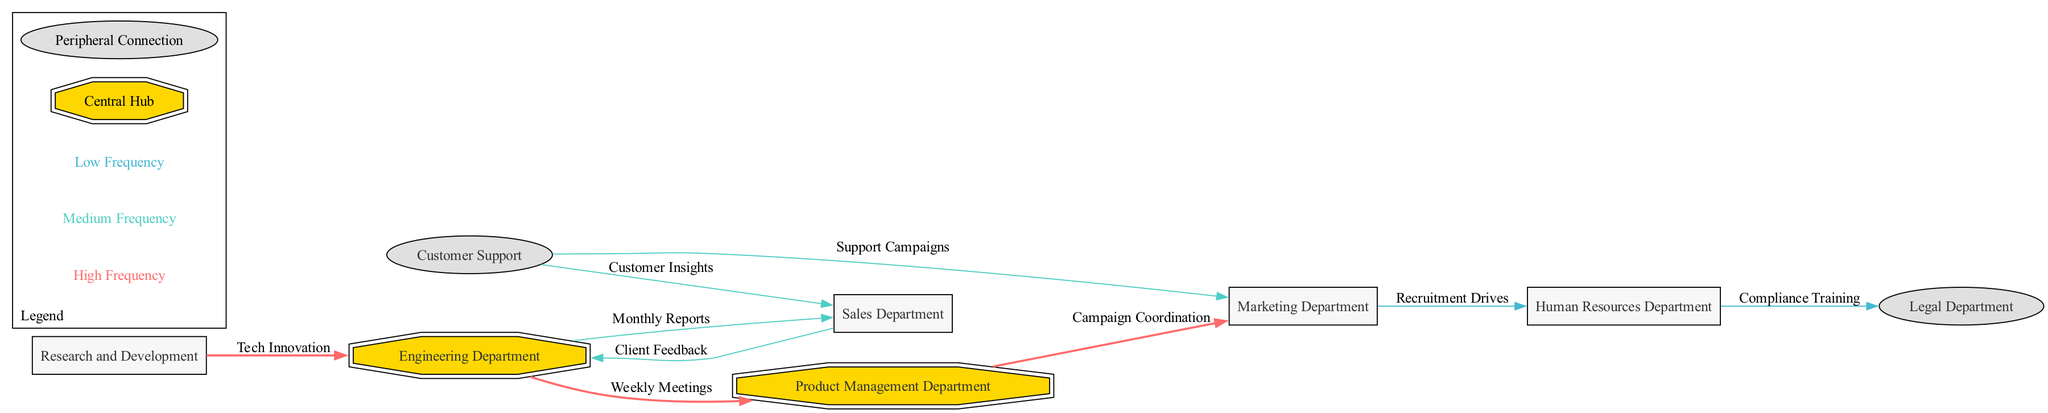What are the central hubs in the organization? The diagram indicates that the central hubs are the Engineering Department and the Product Management Department, as these are highlighted distinctly (double octagon shape) compared to other nodes.
Answer: Engineering Department, Product Management Department How many edges depict high interaction frequency? By analyzing the edges, we find three labeled as having high interaction frequency: Engineering to Product Management, Product Management to Marketing, and Research and Development to Engineering.
Answer: 3 What is the relationship between the Engineering Department and Customer Support? The diagram shows no direct edge between these two departments, indicating that they do not have recorded interactions in this visualization.
Answer: None Which department has the lowest interaction frequency depicted in the diagram? Evaluating the edges, the connections between Marketing and Human Resources and between Human Resources and Legal have a low interaction frequency as labeled.
Answer: Human Resources Department What department collaborates with the Product Management Department for campaign coordination? The edge labeled "Campaign Coordination" shows that the Product Management Department collaborates with the Marketing Department, signifying a high level of interaction.
Answer: Marketing Department How many departments are connected to the Engineering Department? One can count the edges connected to the Engineering Department: it connects to Product Management, Research and Development, and Sales, totaling three connections.
Answer: 3 Which department appears to be classified as a peripheral connection? The diagram categorizes the Legal Department and Customer Support as peripheral connections, indicating they play a less central role in inter-departmental collaborations.
Answer: Legal Department, Customer Support What type of meetings occur between Engineering and Product Management? The edge labeled "Weekly Meetings" illustrates that these two departments hold regular meetings, highlighting their frequent collaboration.
Answer: Weekly Meetings How often do Customer Support and Sales interact based on the diagram? The interaction between Customer Support and Sales is indicated as "Medium" frequency, reflecting some level of collaboration yet not as frequent as other connections.
Answer: Medium 